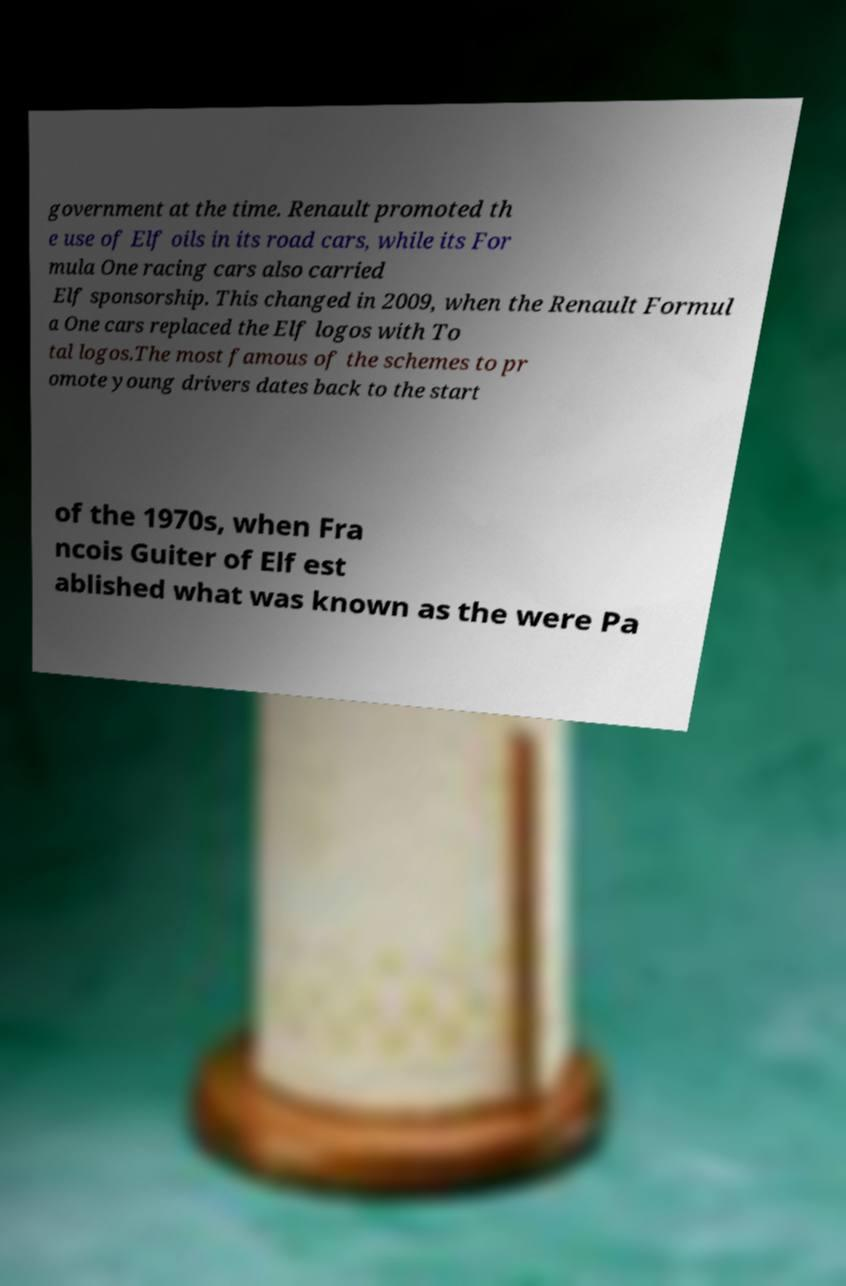Could you extract and type out the text from this image? government at the time. Renault promoted th e use of Elf oils in its road cars, while its For mula One racing cars also carried Elf sponsorship. This changed in 2009, when the Renault Formul a One cars replaced the Elf logos with To tal logos.The most famous of the schemes to pr omote young drivers dates back to the start of the 1970s, when Fra ncois Guiter of Elf est ablished what was known as the were Pa 